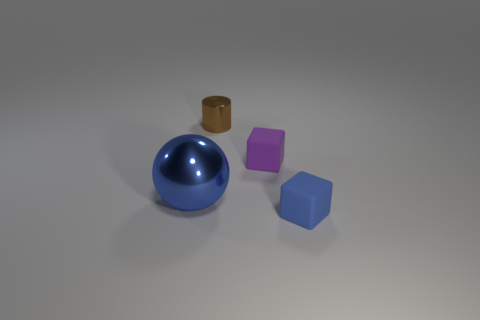Describe the lighting and shadows visible in the image. The lighting in the image appears to be diffused, likely from an overhead source, judging by the soft shadows cast by the objects. The shadows are on the right side of the objects, suggesting the light source is to the left. 